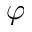Convert formula to latex. <formula><loc_0><loc_0><loc_500><loc_500>\varphi</formula> 